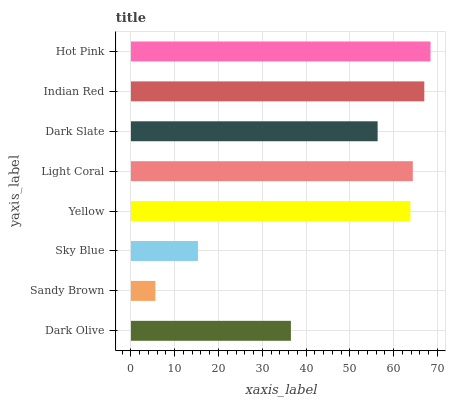Is Sandy Brown the minimum?
Answer yes or no. Yes. Is Hot Pink the maximum?
Answer yes or no. Yes. Is Sky Blue the minimum?
Answer yes or no. No. Is Sky Blue the maximum?
Answer yes or no. No. Is Sky Blue greater than Sandy Brown?
Answer yes or no. Yes. Is Sandy Brown less than Sky Blue?
Answer yes or no. Yes. Is Sandy Brown greater than Sky Blue?
Answer yes or no. No. Is Sky Blue less than Sandy Brown?
Answer yes or no. No. Is Yellow the high median?
Answer yes or no. Yes. Is Dark Slate the low median?
Answer yes or no. Yes. Is Hot Pink the high median?
Answer yes or no. No. Is Sky Blue the low median?
Answer yes or no. No. 